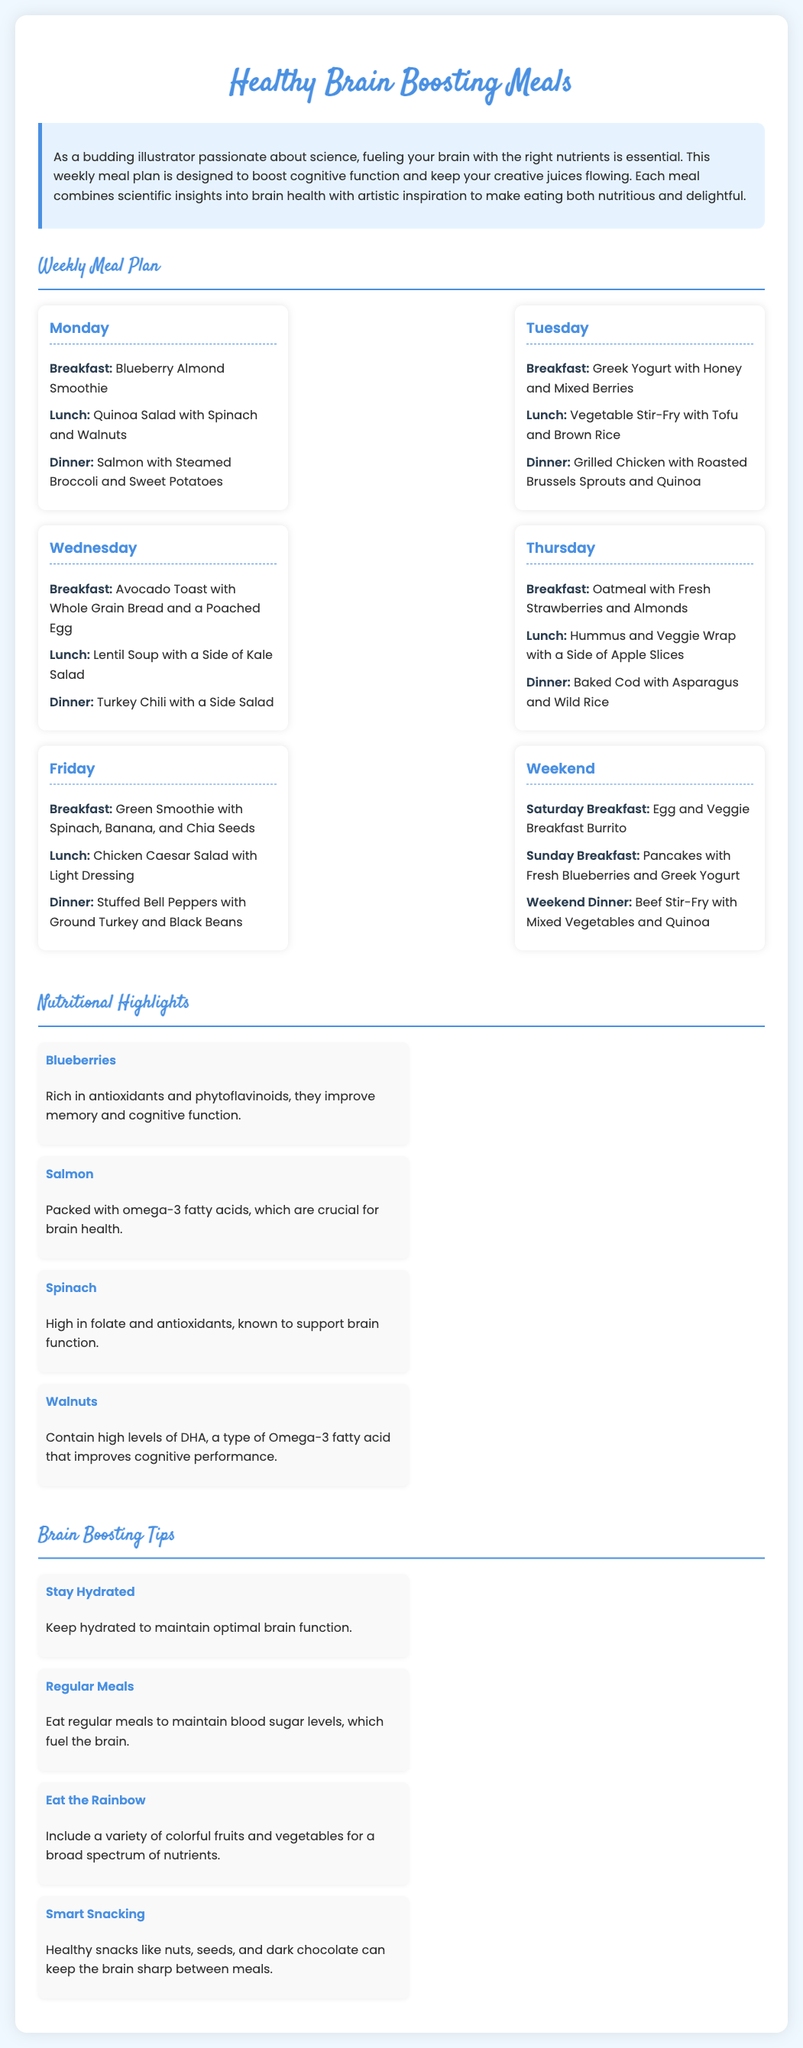What is the title of the document? The title is mentioned in the `<title>` tag in the head section of the HTML document.
Answer: Healthy Brain Boosting Meals What meal is served for breakfast on Monday? The breakfast item for Monday is listed in the meal plan section of the document under Monday's offerings.
Answer: Blueberry Almond Smoothie Which meal features walnuts as a nutritional highlight? The nutritional highlights section identifies which foods contain walnuts and their benefits.
Answer: Quinoa Salad with Spinach and Walnuts What day of the week includes grilled chicken for dinner? The dinner meal for grilled chicken can be found in the Tuesday section of the meal plan.
Answer: Tuesday How many types of brain boosting tips are provided? The tips section lists several tips, counting how many are mentioned can give the answer.
Answer: Four What is the primary benefit of consuming blueberries as mentioned? The document highlights the benefits of blueberries in the nutritional highlights section.
Answer: Improve memory and cognitive function What type of meal is a hummus and veggie wrap? The meal type is typically specified as either breakfast, lunch, or dinner throughout the document.
Answer: Lunch What color of fruits and vegetables does the document encourage including? The tip section specifically mentions a concept related to color in the diet.
Answer: Rainbow 